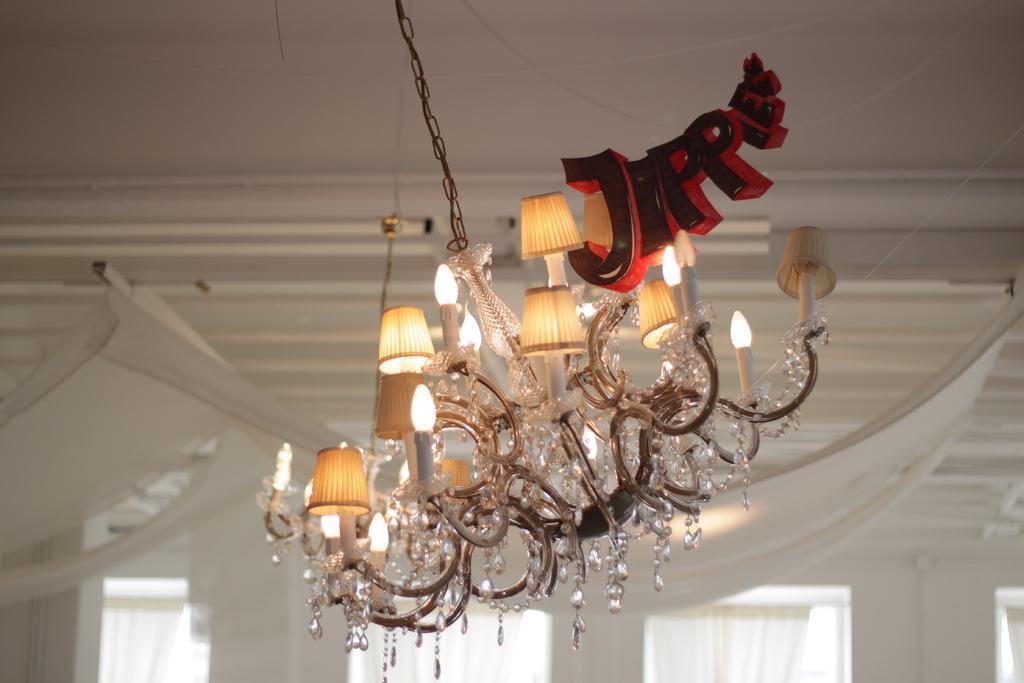In one or two sentences, can you explain what this image depicts? In this image I can see there are lights, at the bottom there are white color curtains to the windows. 